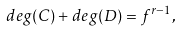<formula> <loc_0><loc_0><loc_500><loc_500>d e g ( C ) + d e g ( D ) = f ^ { r - 1 } ,</formula> 